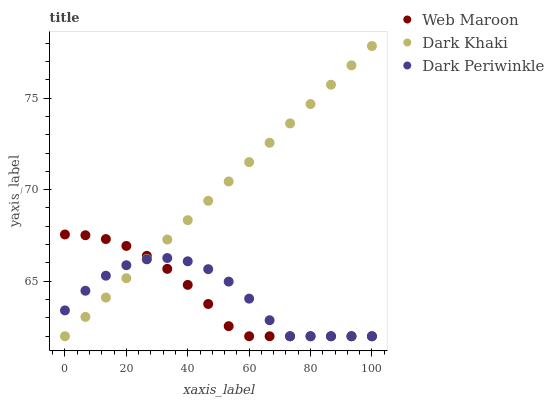Does Web Maroon have the minimum area under the curve?
Answer yes or no. Yes. Does Dark Khaki have the maximum area under the curve?
Answer yes or no. Yes. Does Dark Periwinkle have the minimum area under the curve?
Answer yes or no. No. Does Dark Periwinkle have the maximum area under the curve?
Answer yes or no. No. Is Dark Khaki the smoothest?
Answer yes or no. Yes. Is Dark Periwinkle the roughest?
Answer yes or no. Yes. Is Web Maroon the smoothest?
Answer yes or no. No. Is Web Maroon the roughest?
Answer yes or no. No. Does Dark Khaki have the lowest value?
Answer yes or no. Yes. Does Dark Khaki have the highest value?
Answer yes or no. Yes. Does Web Maroon have the highest value?
Answer yes or no. No. Does Dark Khaki intersect Web Maroon?
Answer yes or no. Yes. Is Dark Khaki less than Web Maroon?
Answer yes or no. No. Is Dark Khaki greater than Web Maroon?
Answer yes or no. No. 